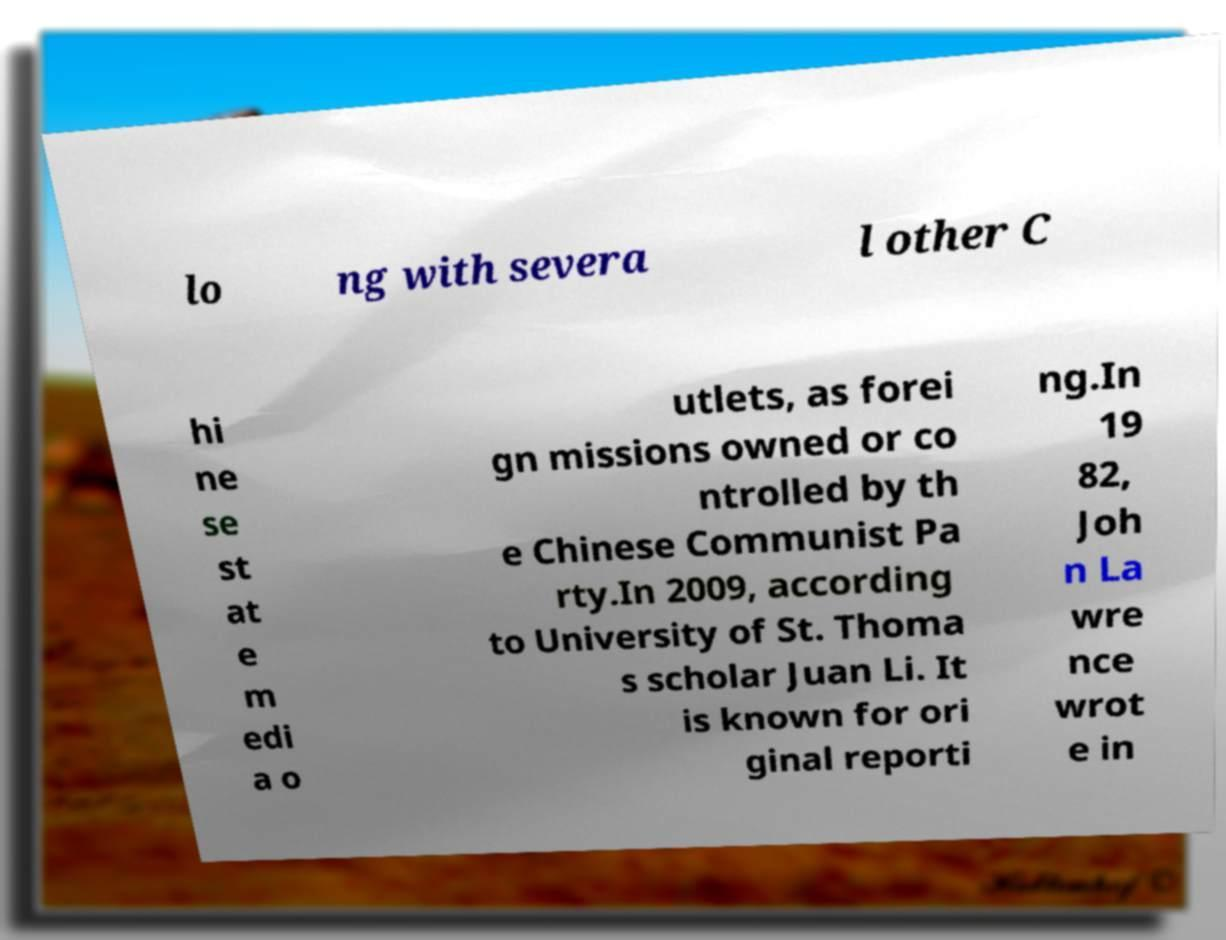Could you extract and type out the text from this image? lo ng with severa l other C hi ne se st at e m edi a o utlets, as forei gn missions owned or co ntrolled by th e Chinese Communist Pa rty.In 2009, according to University of St. Thoma s scholar Juan Li. It is known for ori ginal reporti ng.In 19 82, Joh n La wre nce wrot e in 